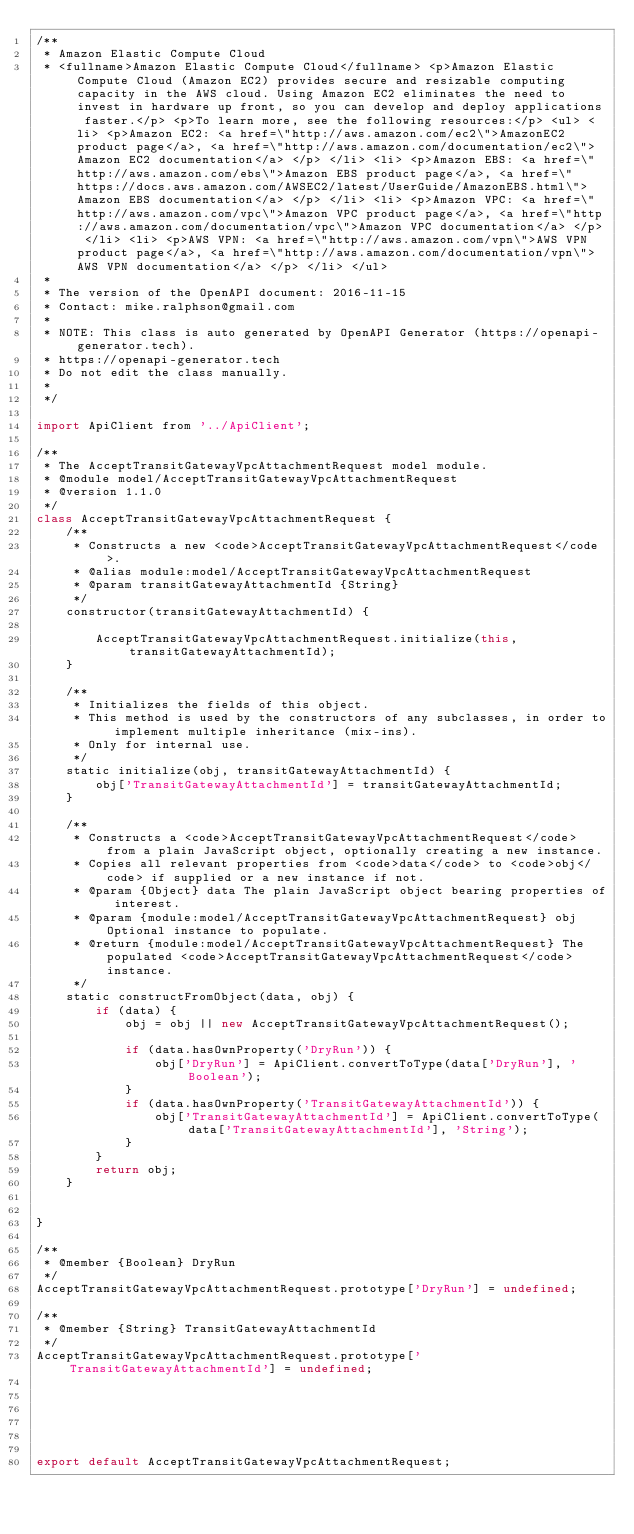<code> <loc_0><loc_0><loc_500><loc_500><_JavaScript_>/**
 * Amazon Elastic Compute Cloud
 * <fullname>Amazon Elastic Compute Cloud</fullname> <p>Amazon Elastic Compute Cloud (Amazon EC2) provides secure and resizable computing capacity in the AWS cloud. Using Amazon EC2 eliminates the need to invest in hardware up front, so you can develop and deploy applications faster.</p> <p>To learn more, see the following resources:</p> <ul> <li> <p>Amazon EC2: <a href=\"http://aws.amazon.com/ec2\">AmazonEC2 product page</a>, <a href=\"http://aws.amazon.com/documentation/ec2\">Amazon EC2 documentation</a> </p> </li> <li> <p>Amazon EBS: <a href=\"http://aws.amazon.com/ebs\">Amazon EBS product page</a>, <a href=\"https://docs.aws.amazon.com/AWSEC2/latest/UserGuide/AmazonEBS.html\">Amazon EBS documentation</a> </p> </li> <li> <p>Amazon VPC: <a href=\"http://aws.amazon.com/vpc\">Amazon VPC product page</a>, <a href=\"http://aws.amazon.com/documentation/vpc\">Amazon VPC documentation</a> </p> </li> <li> <p>AWS VPN: <a href=\"http://aws.amazon.com/vpn\">AWS VPN product page</a>, <a href=\"http://aws.amazon.com/documentation/vpn\">AWS VPN documentation</a> </p> </li> </ul>
 *
 * The version of the OpenAPI document: 2016-11-15
 * Contact: mike.ralphson@gmail.com
 *
 * NOTE: This class is auto generated by OpenAPI Generator (https://openapi-generator.tech).
 * https://openapi-generator.tech
 * Do not edit the class manually.
 *
 */

import ApiClient from '../ApiClient';

/**
 * The AcceptTransitGatewayVpcAttachmentRequest model module.
 * @module model/AcceptTransitGatewayVpcAttachmentRequest
 * @version 1.1.0
 */
class AcceptTransitGatewayVpcAttachmentRequest {
    /**
     * Constructs a new <code>AcceptTransitGatewayVpcAttachmentRequest</code>.
     * @alias module:model/AcceptTransitGatewayVpcAttachmentRequest
     * @param transitGatewayAttachmentId {String} 
     */
    constructor(transitGatewayAttachmentId) { 
        
        AcceptTransitGatewayVpcAttachmentRequest.initialize(this, transitGatewayAttachmentId);
    }

    /**
     * Initializes the fields of this object.
     * This method is used by the constructors of any subclasses, in order to implement multiple inheritance (mix-ins).
     * Only for internal use.
     */
    static initialize(obj, transitGatewayAttachmentId) { 
        obj['TransitGatewayAttachmentId'] = transitGatewayAttachmentId;
    }

    /**
     * Constructs a <code>AcceptTransitGatewayVpcAttachmentRequest</code> from a plain JavaScript object, optionally creating a new instance.
     * Copies all relevant properties from <code>data</code> to <code>obj</code> if supplied or a new instance if not.
     * @param {Object} data The plain JavaScript object bearing properties of interest.
     * @param {module:model/AcceptTransitGatewayVpcAttachmentRequest} obj Optional instance to populate.
     * @return {module:model/AcceptTransitGatewayVpcAttachmentRequest} The populated <code>AcceptTransitGatewayVpcAttachmentRequest</code> instance.
     */
    static constructFromObject(data, obj) {
        if (data) {
            obj = obj || new AcceptTransitGatewayVpcAttachmentRequest();

            if (data.hasOwnProperty('DryRun')) {
                obj['DryRun'] = ApiClient.convertToType(data['DryRun'], 'Boolean');
            }
            if (data.hasOwnProperty('TransitGatewayAttachmentId')) {
                obj['TransitGatewayAttachmentId'] = ApiClient.convertToType(data['TransitGatewayAttachmentId'], 'String');
            }
        }
        return obj;
    }


}

/**
 * @member {Boolean} DryRun
 */
AcceptTransitGatewayVpcAttachmentRequest.prototype['DryRun'] = undefined;

/**
 * @member {String} TransitGatewayAttachmentId
 */
AcceptTransitGatewayVpcAttachmentRequest.prototype['TransitGatewayAttachmentId'] = undefined;






export default AcceptTransitGatewayVpcAttachmentRequest;

</code> 